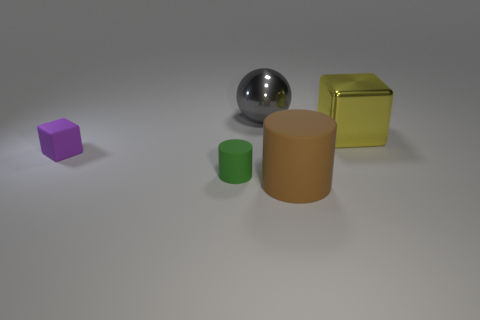Are there fewer large yellow metallic blocks that are behind the green object than objects to the left of the small purple rubber cube?
Your response must be concise. No. Is the shiny ball the same size as the green rubber object?
Your answer should be compact. No. What is the shape of the rubber thing that is both left of the brown cylinder and to the right of the tiny purple object?
Your answer should be compact. Cylinder. What number of big balls have the same material as the yellow cube?
Provide a short and direct response. 1. How many objects are behind the metal object to the right of the brown rubber cylinder?
Offer a terse response. 1. What shape is the shiny object in front of the shiny object left of the cube that is behind the purple rubber block?
Your response must be concise. Cube. How many things are shiny cubes or tiny things?
Offer a terse response. 3. What is the color of the metal cube that is the same size as the gray ball?
Give a very brief answer. Yellow. There is a purple object; is its shape the same as the tiny thing that is right of the tiny rubber block?
Keep it short and to the point. No. How many objects are objects that are right of the gray object or tiny green things to the left of the large matte cylinder?
Provide a succinct answer. 3. 